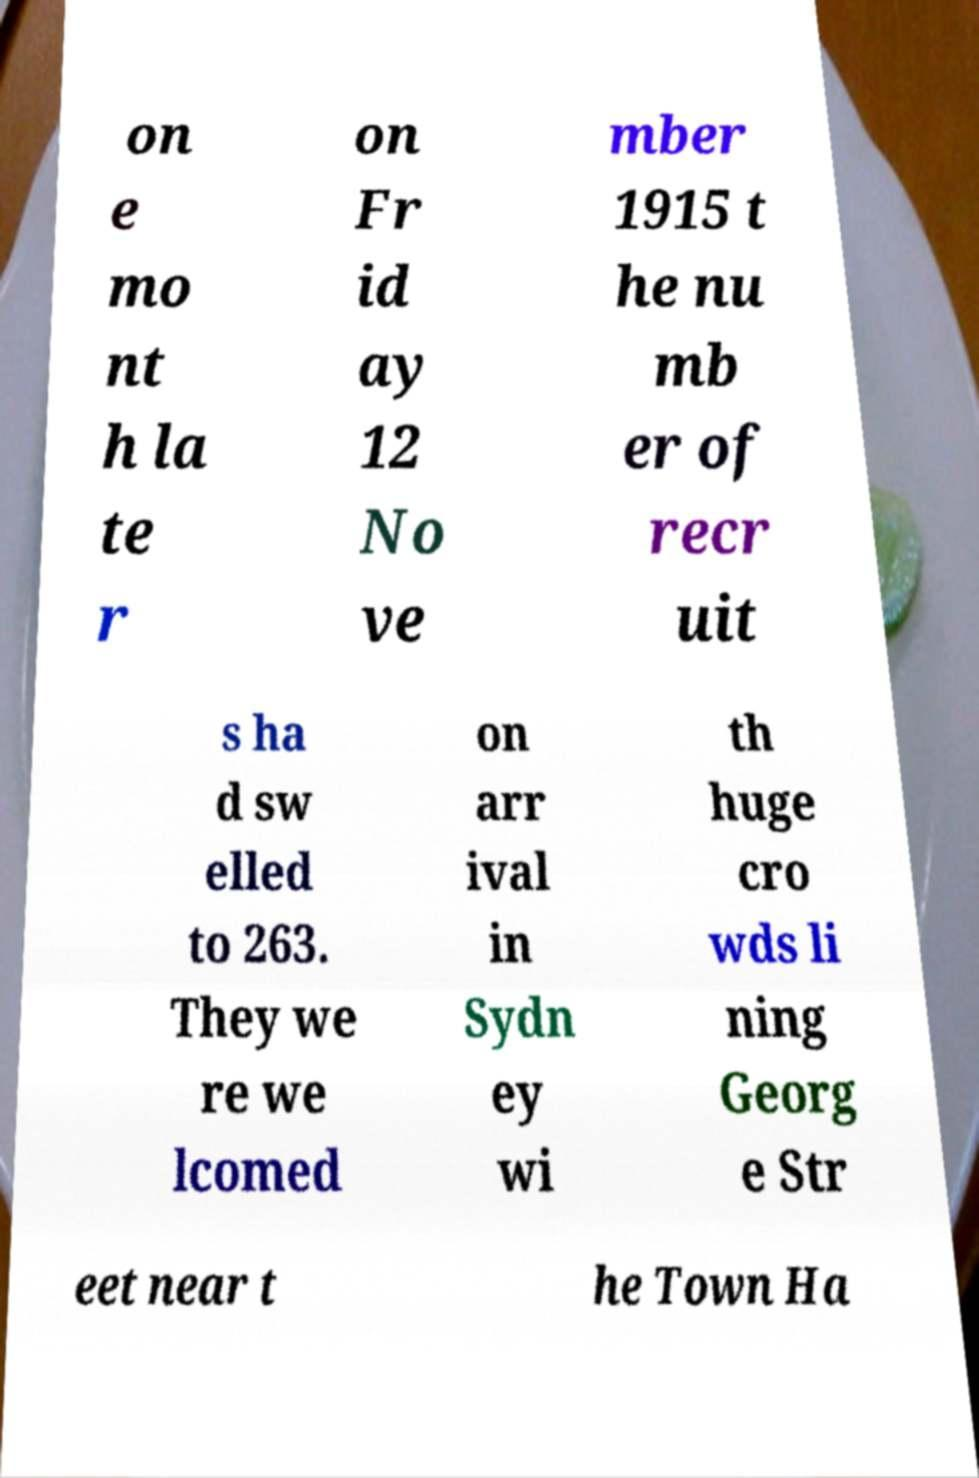There's text embedded in this image that I need extracted. Can you transcribe it verbatim? on e mo nt h la te r on Fr id ay 12 No ve mber 1915 t he nu mb er of recr uit s ha d sw elled to 263. They we re we lcomed on arr ival in Sydn ey wi th huge cro wds li ning Georg e Str eet near t he Town Ha 